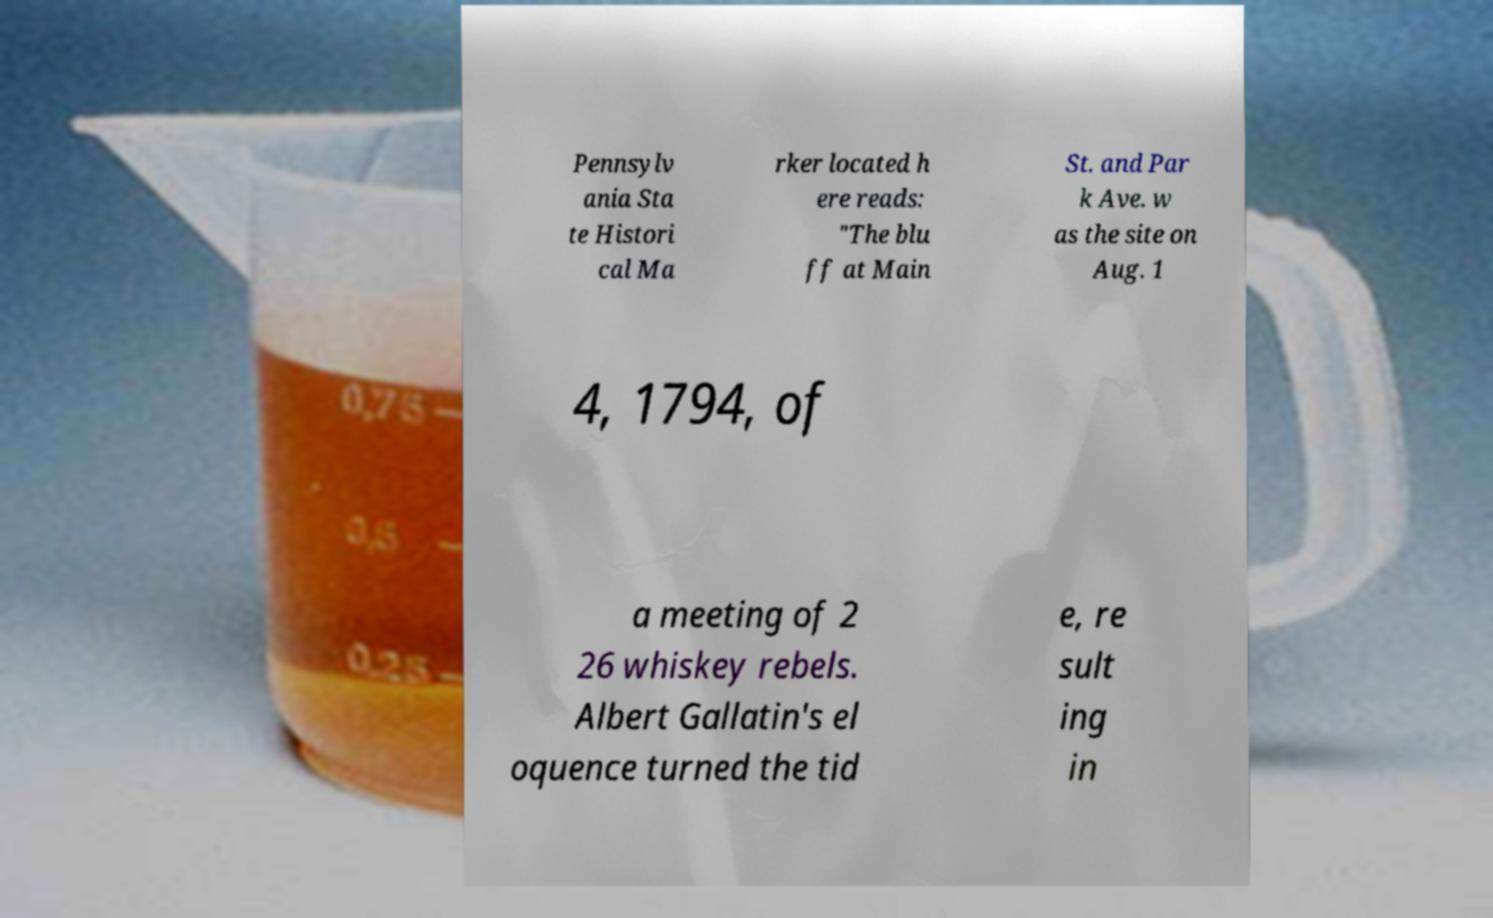What messages or text are displayed in this image? I need them in a readable, typed format. Pennsylv ania Sta te Histori cal Ma rker located h ere reads: "The blu ff at Main St. and Par k Ave. w as the site on Aug. 1 4, 1794, of a meeting of 2 26 whiskey rebels. Albert Gallatin's el oquence turned the tid e, re sult ing in 